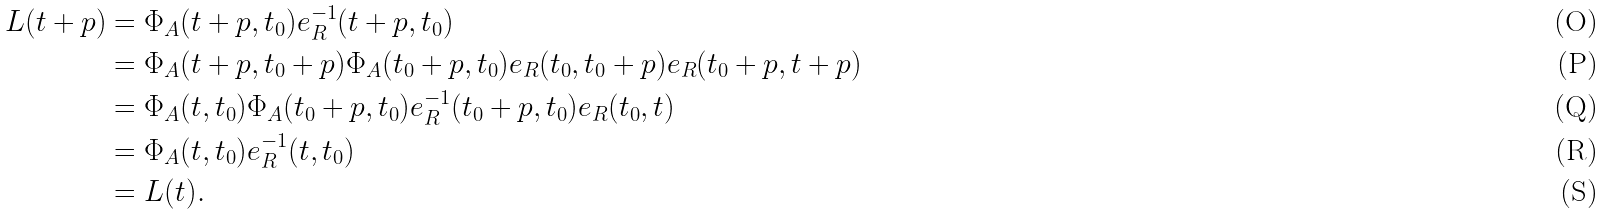<formula> <loc_0><loc_0><loc_500><loc_500>L ( t + p ) & = \Phi _ { A } ( t + p , t _ { 0 } ) e _ { R } ^ { - 1 } ( t + p , t _ { 0 } ) \\ & = \Phi _ { A } ( t + p , t _ { 0 } + p ) \Phi _ { A } ( t _ { 0 } + p , t _ { 0 } ) e _ { R } ( t _ { 0 } , t _ { 0 } + p ) e _ { R } ( t _ { 0 } + p , t + p ) \\ & = \Phi _ { A } ( t , t _ { 0 } ) \Phi _ { A } ( t _ { 0 } + p , t _ { 0 } ) e _ { R } ^ { - 1 } ( t _ { 0 } + p , t _ { 0 } ) e _ { R } ( t _ { 0 } , t ) \\ & = \Phi _ { A } ( t , t _ { 0 } ) e _ { R } ^ { - 1 } ( t , t _ { 0 } ) \\ & = L ( t ) .</formula> 